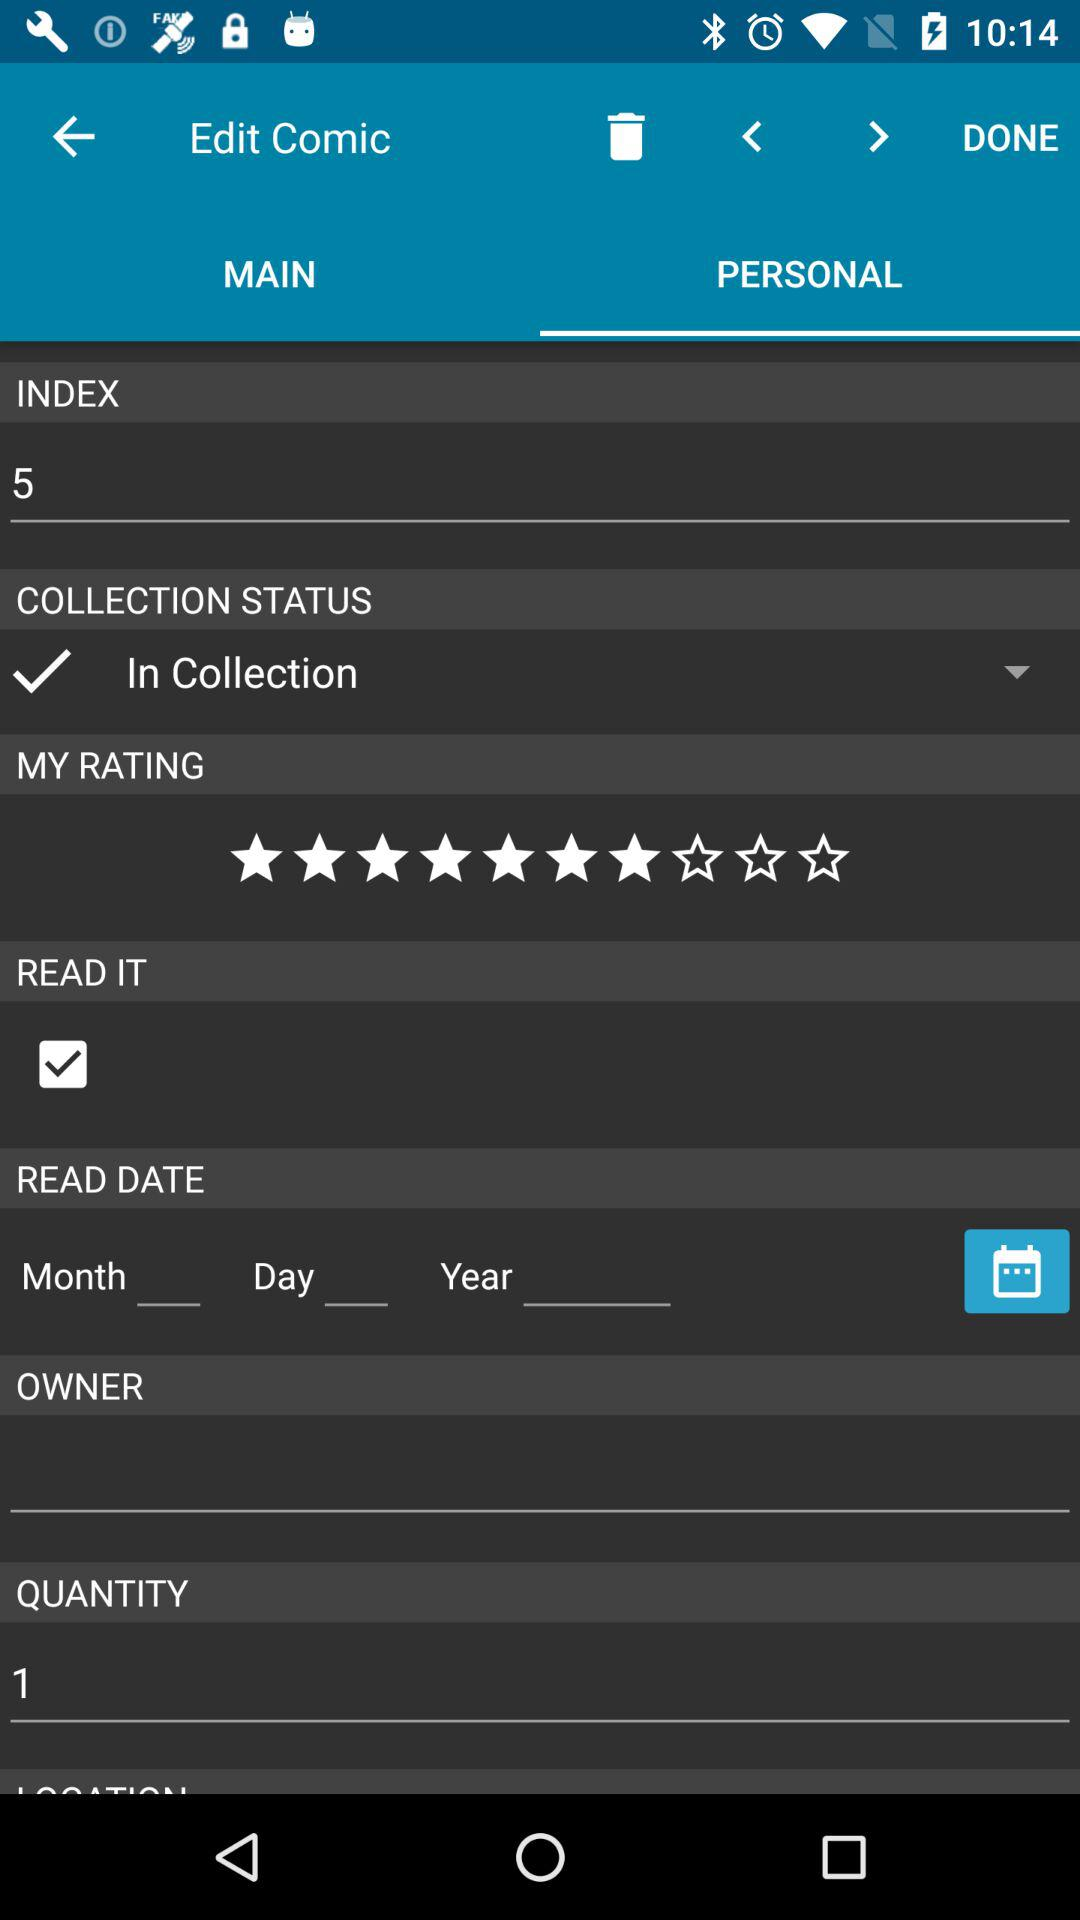Which tab is selected? The selected tab is "PERSONAL". 